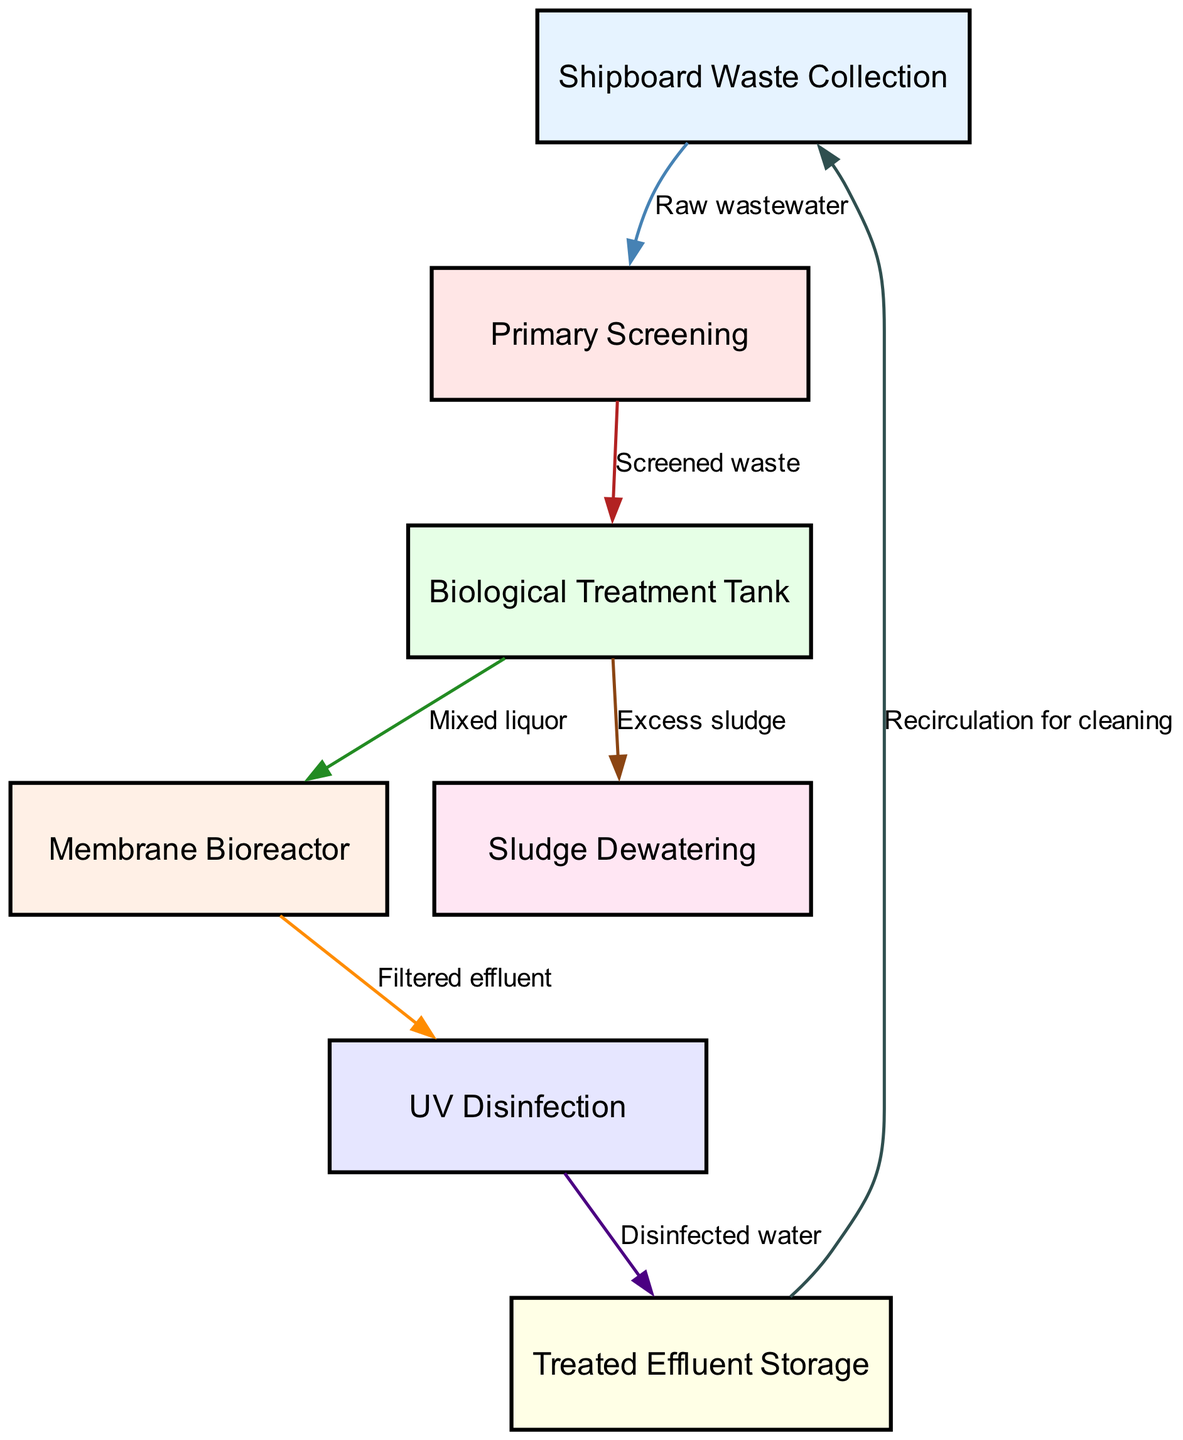What is the first step in the waste management flow? The first step is labeled as "Shipboard Waste Collection", which indicates that it is the initial process in the waste management flow.
Answer: Shipboard Waste Collection How many nodes are present in the diagram? By counting the nodes listed in the diagram data, there are a total of 7 nodes: Shipboard Waste Collection, Primary Screening, Biological Treatment Tank, Membrane Bioreactor, UV Disinfection, Treated Effluent Storage, and Sludge Dewatering.
Answer: 7 Which node comes after the "Primary Screening"? Following the "Primary Screening", the next node indicated is the "Biological Treatment Tank". This shows the progression of the waste treatment process.
Answer: Biological Treatment Tank What type of waste is processed in the "Biological Treatment Tank"? The waste processed is referred to as "Mixed liquor", which denotes the mixture of screened wastewater and biological agents used for treatment in this tank.
Answer: Mixed liquor What happens to "Excess sludge" after the "Biological Treatment Tank"? The "Excess sludge" is directed to the "Sludge Dewatering" process, which indicates a step where excess by-products from the biological treatment process are managed.
Answer: Sludge Dewatering What is the final output of the treatment process? The final output that is treated and ready for storage is labeled as "Disinfected water", which results from the UV Disinfection step.
Answer: Disinfected water What is the purpose of recirculation for cleaning in this system? The purpose of the recirculation for cleaning is to utilize "Treated Effluent Storage" for additional cleaning processes, ensuring that waste is effectively managed and recycled.
Answer: Recirculation for cleaning How is "Filtered effluent" obtained in the flow? "Filtered effluent" is obtained after the "Membrane Bioreactor" step, indicating that the effluent has undergone filtration to remove contaminants.
Answer: Filtered effluent 